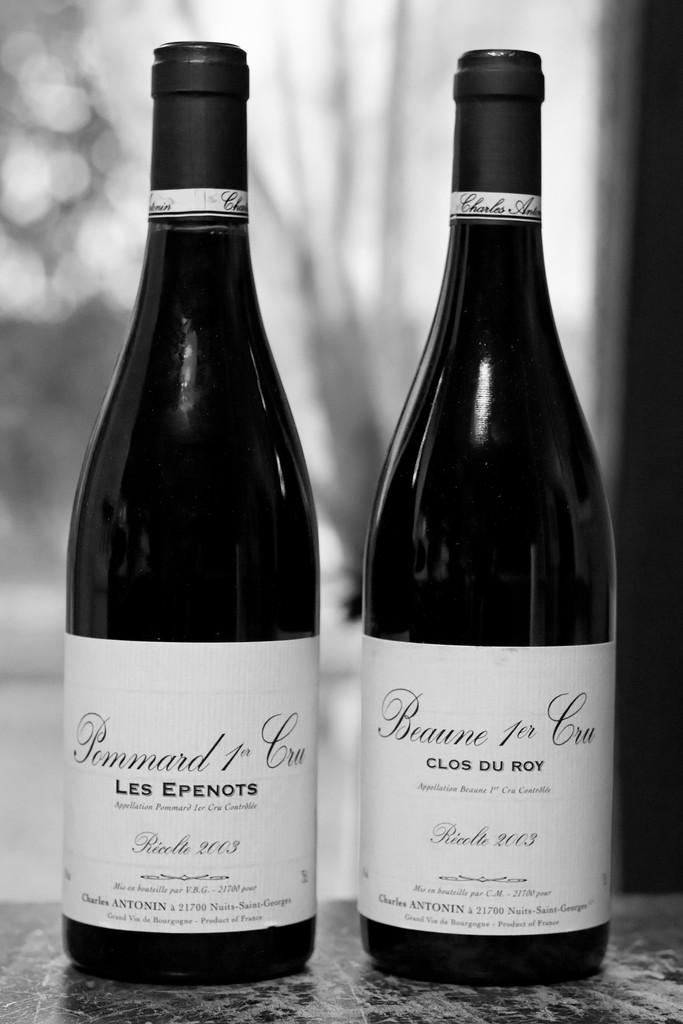How many bottles can be seen in the image? There are two bottles in the image. Where are the bottles located? The bottles are on a surface. What can be found on the bottles? The bottles have labels with text. Can you describe the background of the image? The background of the image is blurry. What type of trail can be seen behind the bottles in the image? There is no trail visible behind the bottles in the image; the background is blurry. 